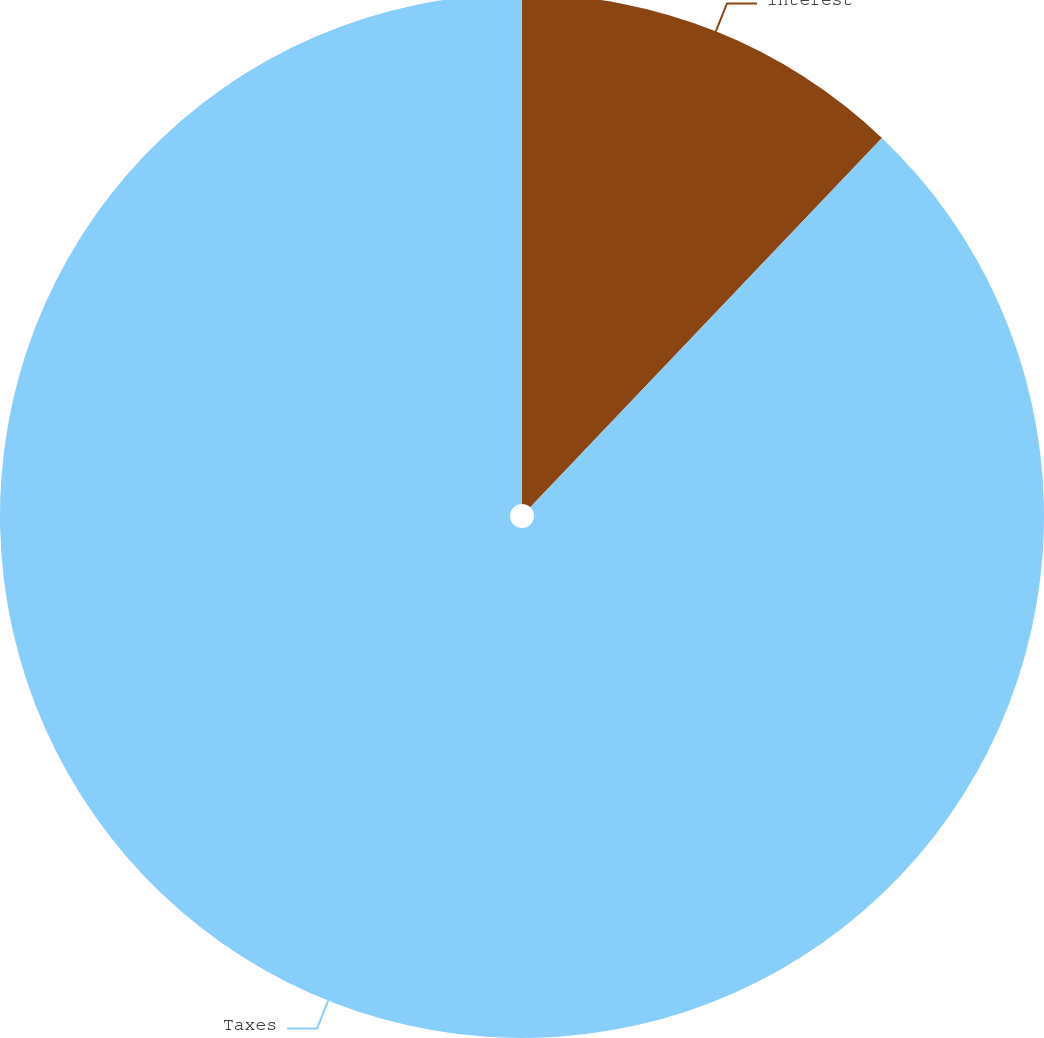Convert chart. <chart><loc_0><loc_0><loc_500><loc_500><pie_chart><fcel>Interest<fcel>Taxes<nl><fcel>12.11%<fcel>87.89%<nl></chart> 